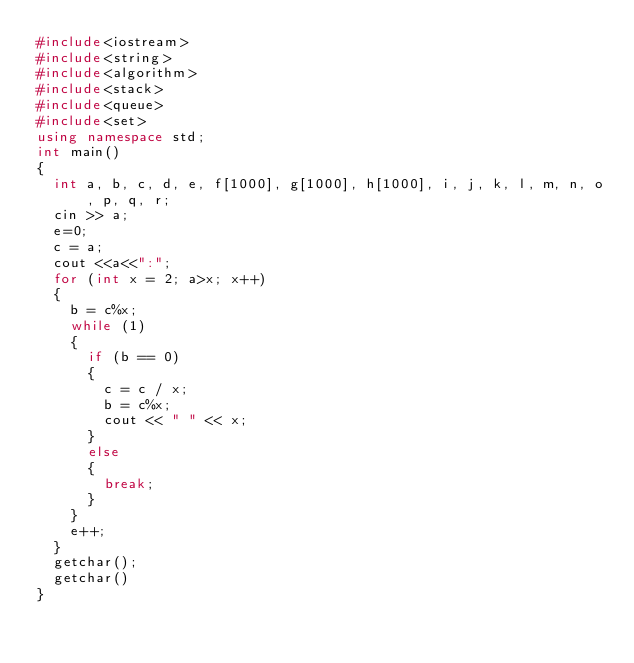<code> <loc_0><loc_0><loc_500><loc_500><_C++_>#include<iostream>
#include<string>
#include<algorithm>
#include<stack>
#include<queue>
#include<set>
using namespace std;
int main()
{
	int a, b, c, d, e, f[1000], g[1000], h[1000], i, j, k, l, m, n, o, p, q, r;
	cin >> a;
	e=0;
	c = a;
	cout <<a<<":";
	for (int x = 2; a>x; x++)
	{
		b = c%x;
		while (1)
		{
			if (b == 0)
			{
				c = c / x;
				b = c%x;
				cout << " " << x;
			}
			else
			{
				break;
			}
		}
		e++;
	}
	getchar();
	getchar()
}</code> 